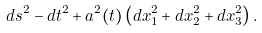<formula> <loc_0><loc_0><loc_500><loc_500>d s ^ { 2 } - d t ^ { 2 } + a ^ { 2 } ( t ) \left ( d x _ { 1 } ^ { 2 } + d x _ { 2 } ^ { 2 } + d x _ { 3 } ^ { 2 } \right ) .</formula> 